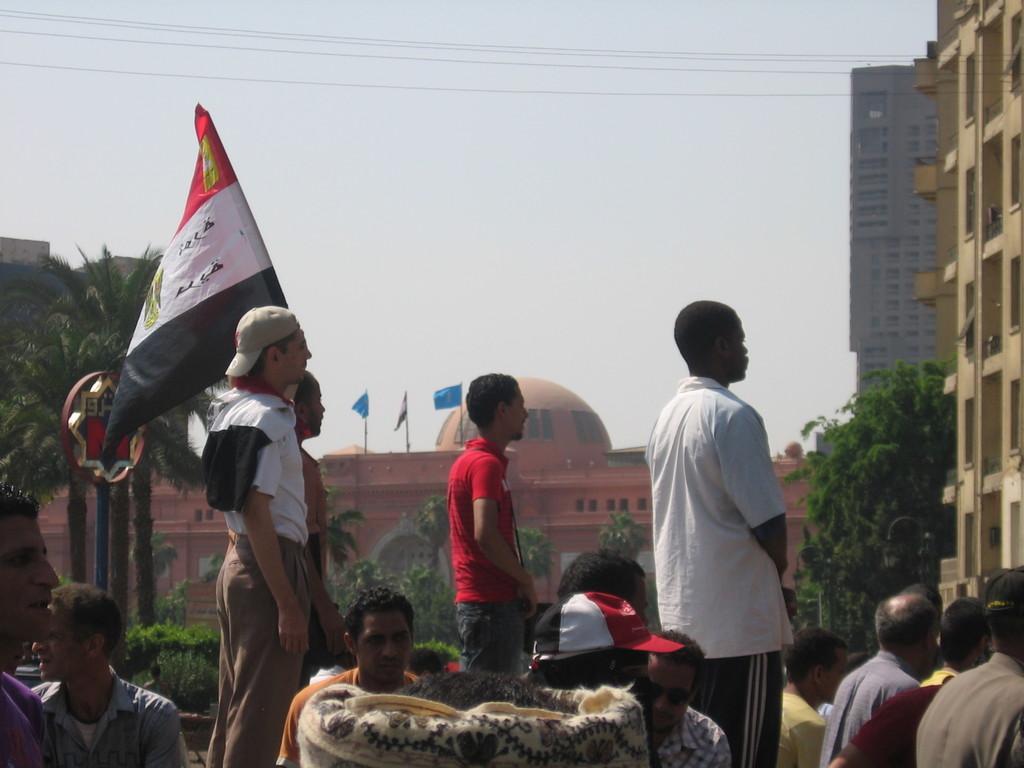How would you summarize this image in a sentence or two? Here men are standing, these are buildings and trees, this is flag and a sky. 